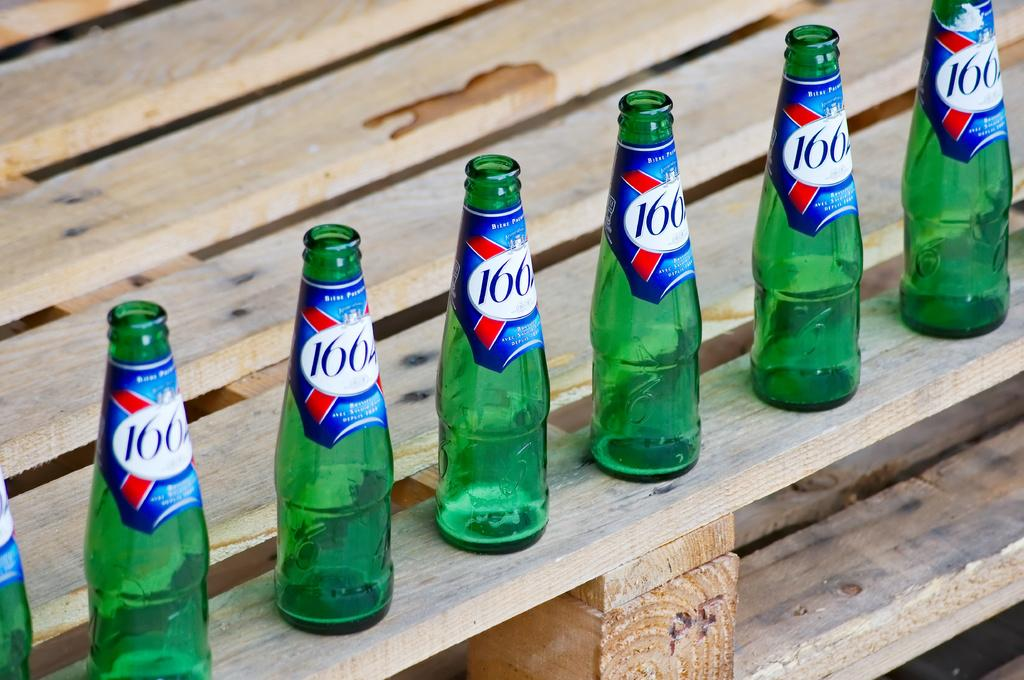Provide a one-sentence caption for the provided image. Various bottles labeled 1664 sit on some wood. 